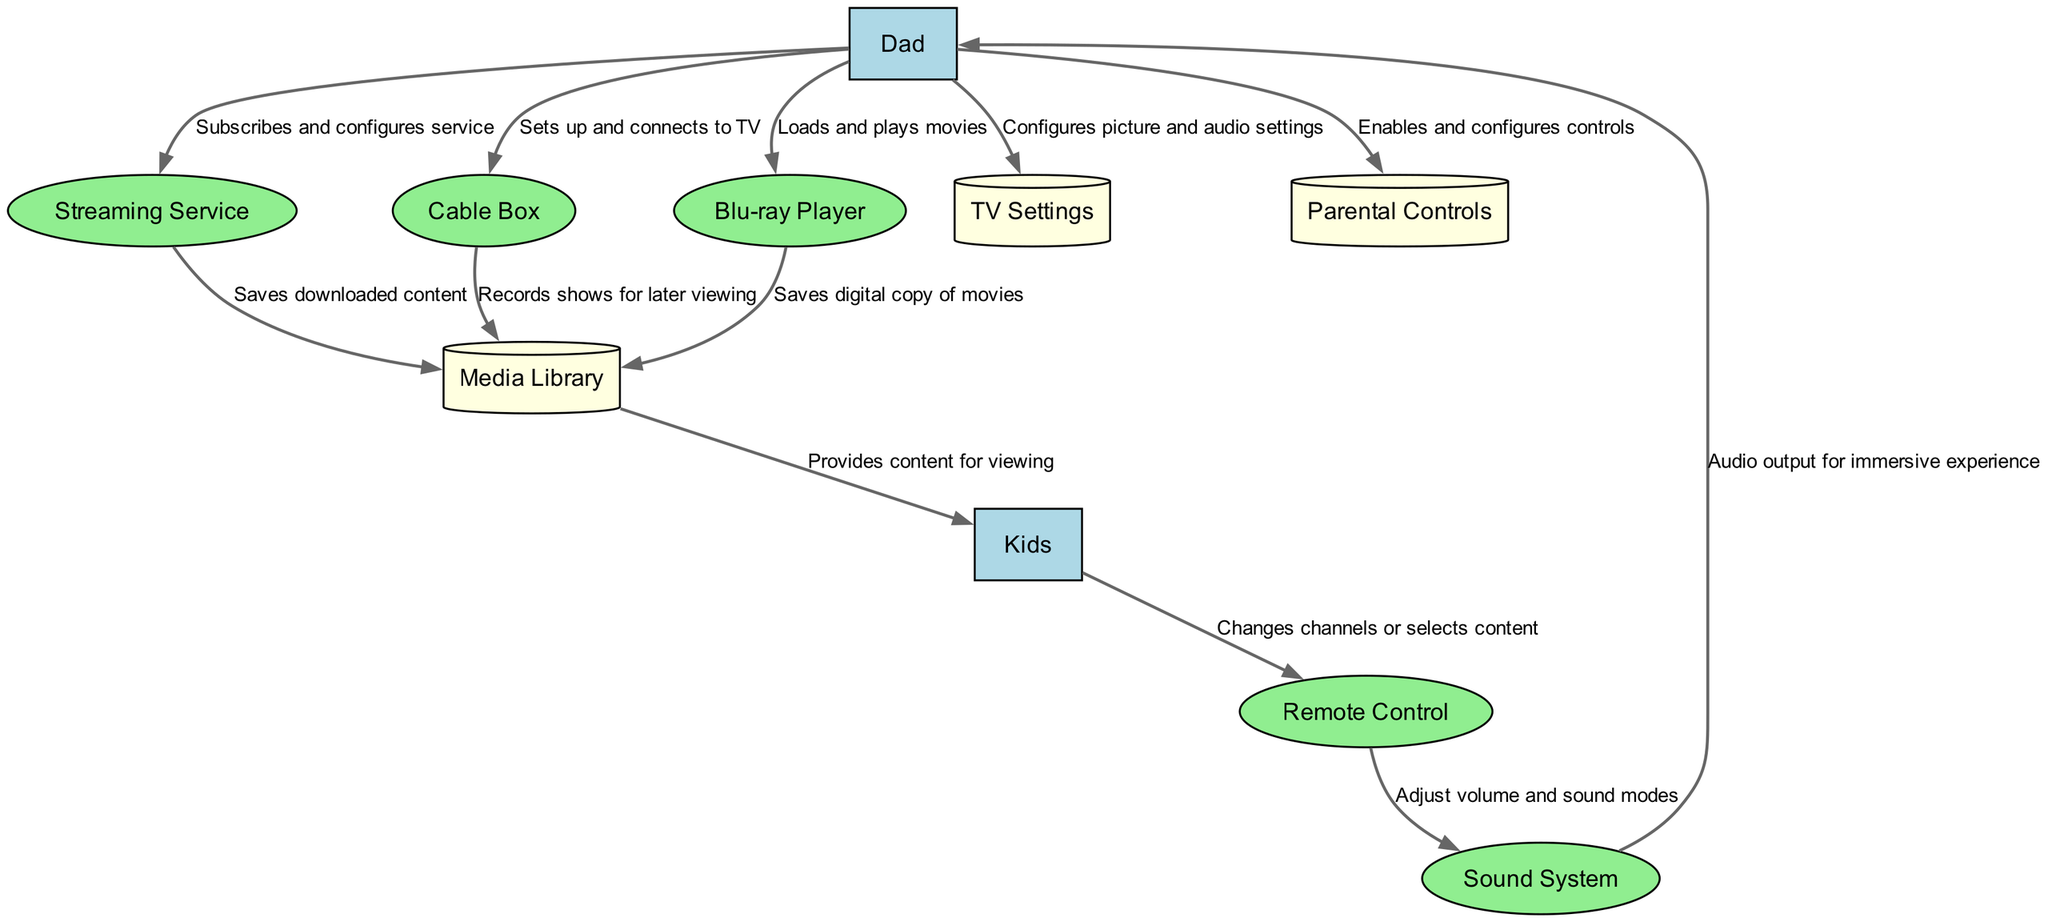What is the first external entity represented in the diagram? The first external entity listed is "Dad," which is identified as the middle-aged dad setting up the entertainment system. This can be confirmed by checking the first item in the "entities" section of the data.
Answer: Dad How many data stores are present in the diagram? The diagram includes three data stores: "Media Library," "TV Settings," and "Parental Controls." By counting these entries in the "entities" section, we can determine the total.
Answer: 3 Which process is responsible for adjusting the audio output? The "Sound System" is responsible for audio output. It is labeled as a process and is linked to "Dad" for audio output purposes, which can be traced from the data flow lines associated with "Sound System."
Answer: Sound System Who provides content for viewing to the kids? The "Media Library" provides content for viewing to the kids, as indicated by the data flow going from "Media Library" to "Kids." This relationship clearly shows the direction of content delivery.
Answer: Media Library Which external entity enables and configures parental controls? "Dad" enables and configures parental controls. The data flow from "Dad" to "Parental Controls" reflects this action clearly, indicating that he is directly responsible for this task.
Answer: Dad How many total processes are shown in the diagram? There are five processes: "Streaming Service," "Cable Box," "Blu-ray Player," "Remote Control," and "Sound System." By counting the entries in the "entities" section specifically under the process type, we reach our total.
Answer: 5 What flow occurs when the kids use the remote control? When the kids use the remote control, the data flow goes from "Kids" to "Remote Control," which indicates that kids change channels or select content. This is where the interaction takes place, as indicated by the data flow description.
Answer: Changes channels or selects content Which data store is used to save downloaded content? The "Media Library" is used to save downloaded content, as represented by the flow from "Streaming Service" to "Media Library," indicating this relationship regarding saving downloaded items.
Answer: Media Library How does "Dad" configure the optimal viewing settings? "Dad" configures the optimal viewing settings by sending a data flow to "TV Settings," where he configures picture and audio settings. This flow indicates the specific interaction that takes place.
Answer: TV Settings 